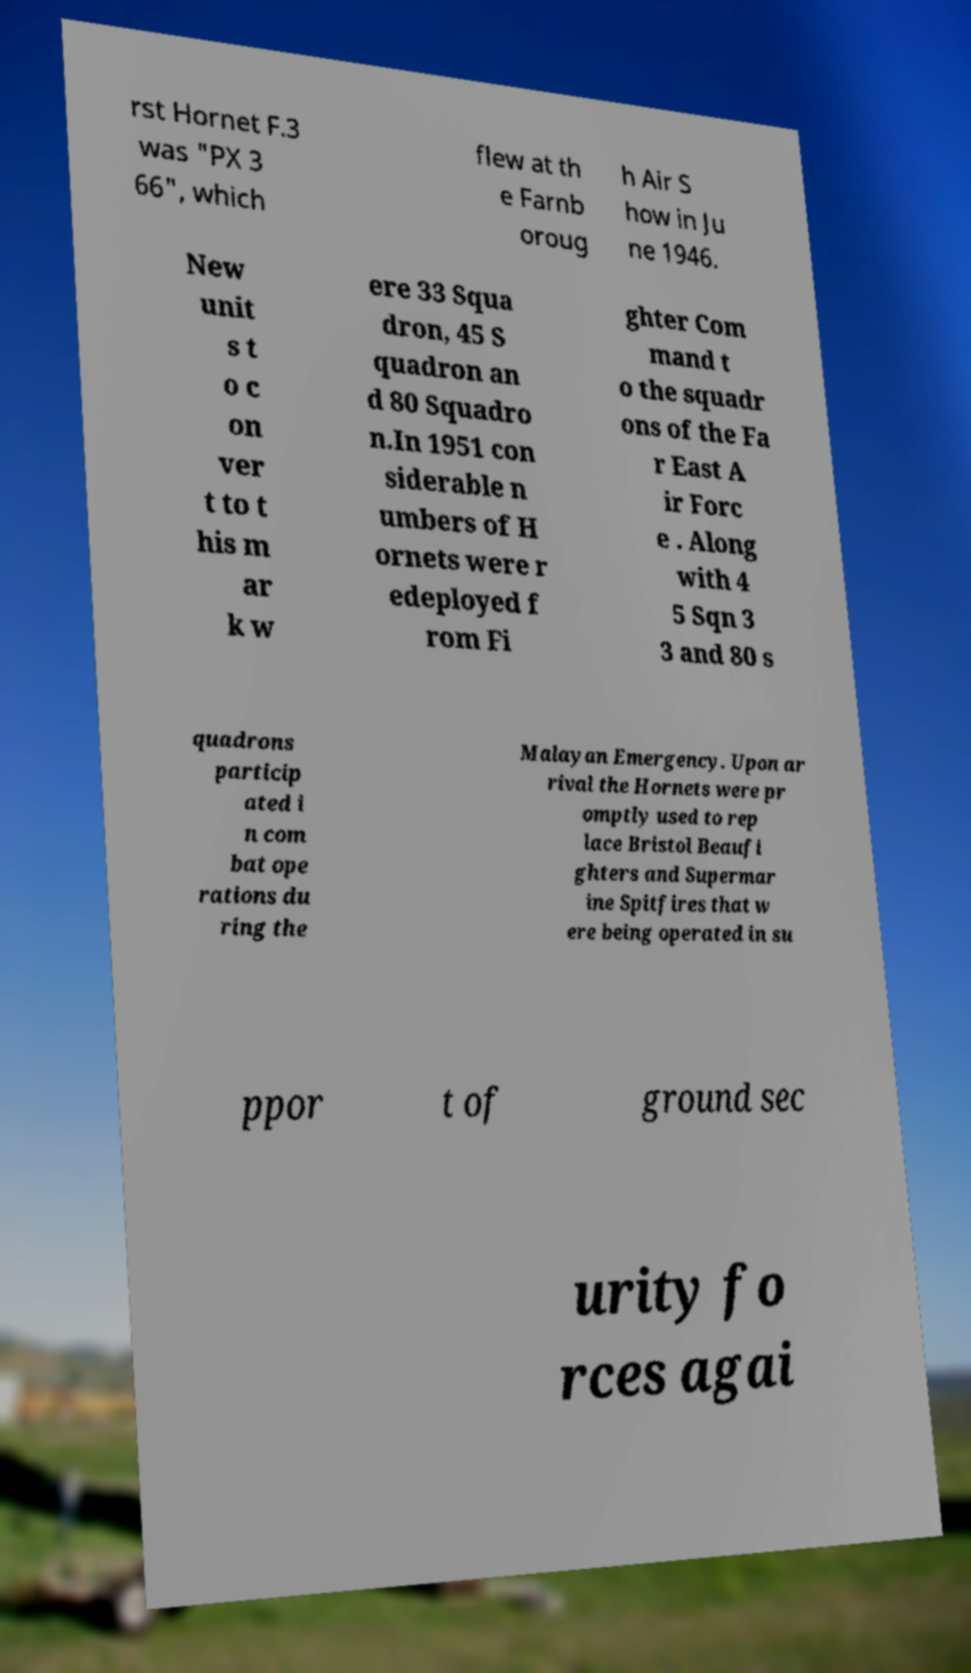Can you read and provide the text displayed in the image?This photo seems to have some interesting text. Can you extract and type it out for me? rst Hornet F.3 was "PX 3 66", which flew at th e Farnb oroug h Air S how in Ju ne 1946. New unit s t o c on ver t to t his m ar k w ere 33 Squa dron, 45 S quadron an d 80 Squadro n.In 1951 con siderable n umbers of H ornets were r edeployed f rom Fi ghter Com mand t o the squadr ons of the Fa r East A ir Forc e . Along with 4 5 Sqn 3 3 and 80 s quadrons particip ated i n com bat ope rations du ring the Malayan Emergency. Upon ar rival the Hornets were pr omptly used to rep lace Bristol Beaufi ghters and Supermar ine Spitfires that w ere being operated in su ppor t of ground sec urity fo rces agai 